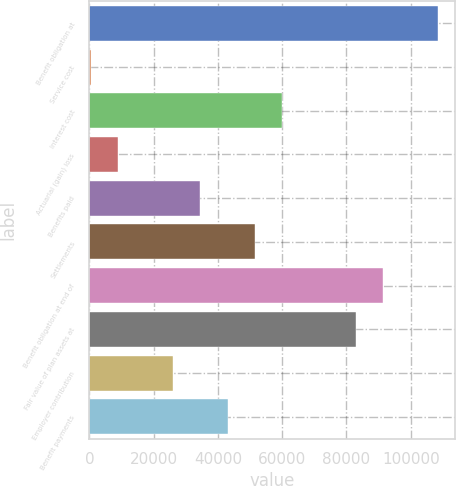Convert chart to OTSL. <chart><loc_0><loc_0><loc_500><loc_500><bar_chart><fcel>Benefit obligation at<fcel>Service cost<fcel>Interest cost<fcel>Actuarial (gain) loss<fcel>Benefits paid<fcel>Settlements<fcel>Benefit obligation at end of<fcel>Fair value of plan assets at<fcel>Employer contribution<fcel>Benefit payments<nl><fcel>108340<fcel>463<fcel>60005<fcel>8969<fcel>34487<fcel>51499<fcel>91328<fcel>82822<fcel>25981<fcel>42993<nl></chart> 